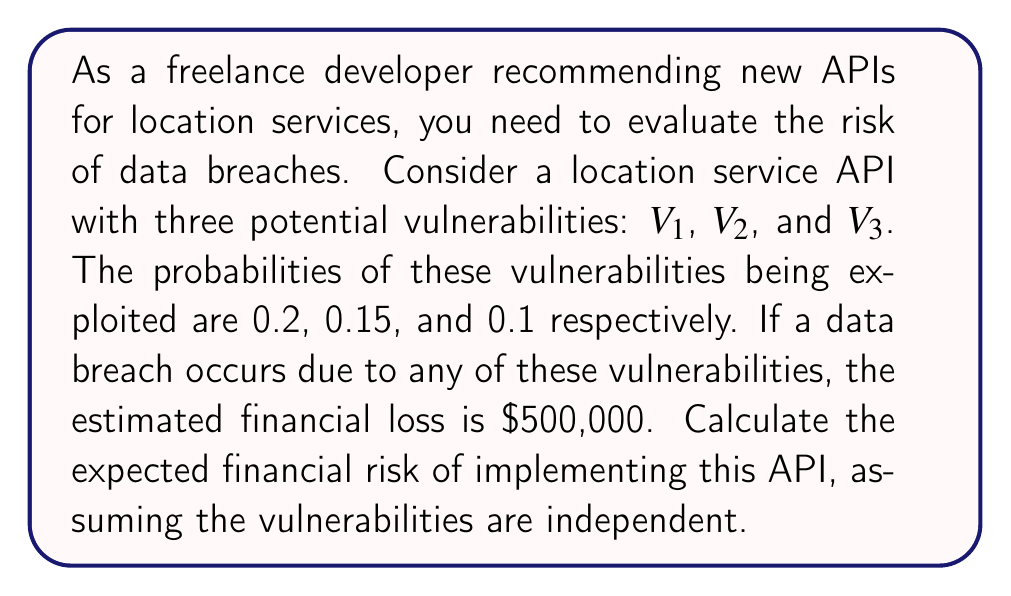Show me your answer to this math problem. To solve this problem, we'll use probabilistic risk assessment techniques:

1. First, let's define our events:
   - V1: Vulnerability 1 is exploited (P(V1) = 0.2)
   - V2: Vulnerability 2 is exploited (P(V2) = 0.15)
   - V3: Vulnerability 3 is exploited (P(V3) = 0.1)

2. We need to calculate the probability of at least one vulnerability being exploited. This is equivalent to 1 minus the probability that none of the vulnerabilities are exploited:

   $P(\text{at least one breach}) = 1 - P(\text{no breach})$

3. Since the vulnerabilities are independent, we can use the multiplication rule of probability:

   $P(\text{no breach}) = P(\text{not V1}) \times P(\text{not V2}) \times P(\text{not V3})$

4. Calculate the probability of no breach:
   $P(\text{no breach}) = (1 - 0.2) \times (1 - 0.15) \times (1 - 0.1)$
   $= 0.8 \times 0.85 \times 0.9$
   $= 0.612$

5. Now, calculate the probability of at least one breach:
   $P(\text{at least one breach}) = 1 - 0.612 = 0.388$

6. The expected financial risk is the product of the probability of a breach and the estimated financial loss:

   $\text{Expected Risk} = P(\text{at least one breach}) \times \text{Financial Loss}$
   $= 0.388 \times \$500,000$
   $= \$194,000$

Therefore, the expected financial risk of implementing this API is $194,000.
Answer: $194,000 